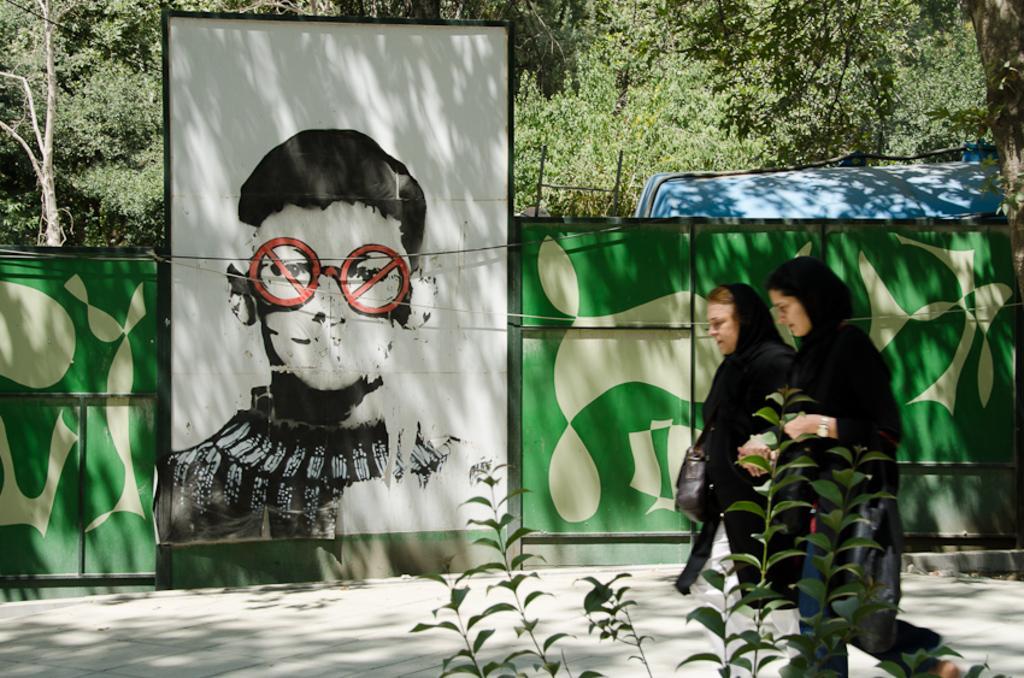In one or two sentences, can you explain what this image depicts? In this image I can see a road in the centre and on it I can see two women are standing. I can see both of them are wearing black colour dress. In the background I can see green colour wall and on it I can see a painting. In the front I can see a plant and in the background I can see number of trees. I can also see a blue colour thing on the right side of this image. 